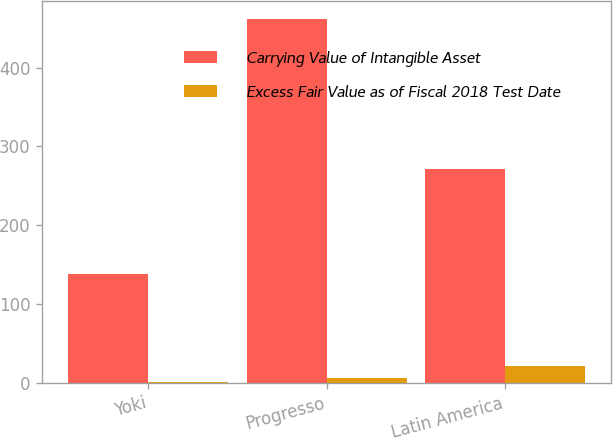<chart> <loc_0><loc_0><loc_500><loc_500><stacked_bar_chart><ecel><fcel>Yoki<fcel>Progresso<fcel>Latin America<nl><fcel>Carrying Value of Intangible Asset<fcel>138.2<fcel>462.1<fcel>272<nl><fcel>Excess Fair Value as of Fiscal 2018 Test Date<fcel>1<fcel>6<fcel>21<nl></chart> 